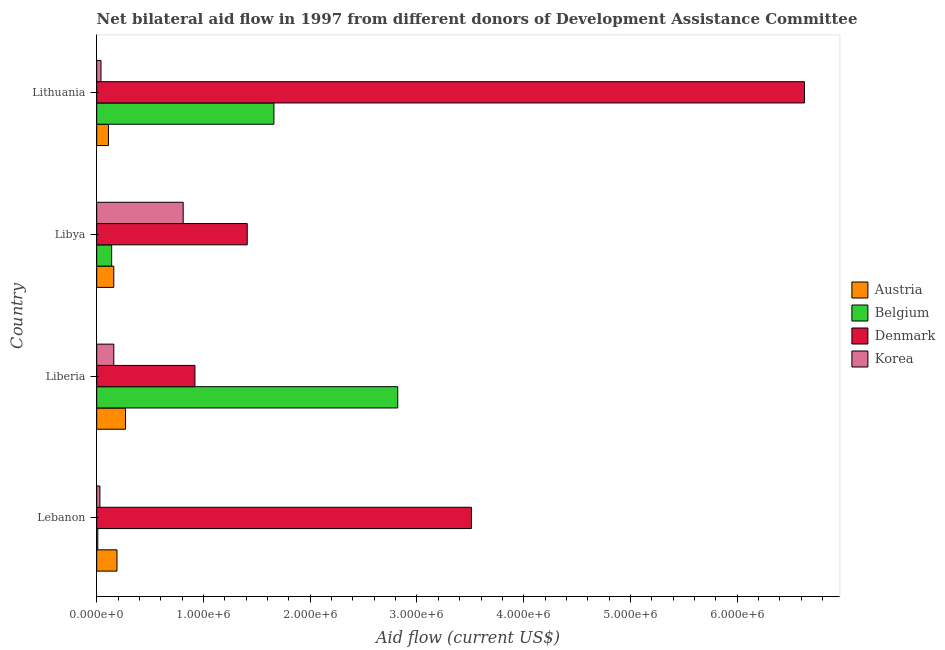How many different coloured bars are there?
Keep it short and to the point. 4. How many bars are there on the 1st tick from the top?
Your answer should be compact. 4. How many bars are there on the 4th tick from the bottom?
Your response must be concise. 4. What is the label of the 3rd group of bars from the top?
Offer a terse response. Liberia. What is the amount of aid given by belgium in Lebanon?
Keep it short and to the point. 10000. Across all countries, what is the maximum amount of aid given by korea?
Ensure brevity in your answer.  8.10e+05. Across all countries, what is the minimum amount of aid given by belgium?
Your answer should be compact. 10000. In which country was the amount of aid given by korea maximum?
Provide a short and direct response. Libya. In which country was the amount of aid given by austria minimum?
Offer a very short reply. Lithuania. What is the total amount of aid given by korea in the graph?
Provide a short and direct response. 1.04e+06. What is the difference between the amount of aid given by austria in Lebanon and that in Libya?
Offer a very short reply. 3.00e+04. What is the difference between the amount of aid given by korea in Lebanon and the amount of aid given by belgium in Liberia?
Provide a succinct answer. -2.79e+06. What is the average amount of aid given by korea per country?
Offer a terse response. 2.60e+05. What is the difference between the amount of aid given by austria and amount of aid given by denmark in Lebanon?
Provide a short and direct response. -3.32e+06. What is the ratio of the amount of aid given by korea in Lebanon to that in Libya?
Your answer should be very brief. 0.04. What is the difference between the highest and the second highest amount of aid given by denmark?
Provide a succinct answer. 3.12e+06. What is the difference between the highest and the lowest amount of aid given by korea?
Offer a terse response. 7.80e+05. Is the sum of the amount of aid given by belgium in Liberia and Lithuania greater than the maximum amount of aid given by denmark across all countries?
Make the answer very short. No. What does the 2nd bar from the top in Lebanon represents?
Your response must be concise. Denmark. Is it the case that in every country, the sum of the amount of aid given by austria and amount of aid given by belgium is greater than the amount of aid given by denmark?
Give a very brief answer. No. What is the difference between two consecutive major ticks on the X-axis?
Give a very brief answer. 1.00e+06. Does the graph contain any zero values?
Provide a short and direct response. No. Where does the legend appear in the graph?
Offer a very short reply. Center right. How many legend labels are there?
Your response must be concise. 4. How are the legend labels stacked?
Make the answer very short. Vertical. What is the title of the graph?
Your answer should be compact. Net bilateral aid flow in 1997 from different donors of Development Assistance Committee. What is the label or title of the X-axis?
Provide a succinct answer. Aid flow (current US$). What is the label or title of the Y-axis?
Offer a terse response. Country. What is the Aid flow (current US$) of Belgium in Lebanon?
Keep it short and to the point. 10000. What is the Aid flow (current US$) of Denmark in Lebanon?
Offer a terse response. 3.51e+06. What is the Aid flow (current US$) of Austria in Liberia?
Offer a terse response. 2.70e+05. What is the Aid flow (current US$) of Belgium in Liberia?
Offer a terse response. 2.82e+06. What is the Aid flow (current US$) of Denmark in Liberia?
Keep it short and to the point. 9.20e+05. What is the Aid flow (current US$) in Austria in Libya?
Provide a succinct answer. 1.60e+05. What is the Aid flow (current US$) in Belgium in Libya?
Offer a very short reply. 1.40e+05. What is the Aid flow (current US$) of Denmark in Libya?
Keep it short and to the point. 1.41e+06. What is the Aid flow (current US$) in Korea in Libya?
Offer a terse response. 8.10e+05. What is the Aid flow (current US$) in Belgium in Lithuania?
Provide a succinct answer. 1.66e+06. What is the Aid flow (current US$) of Denmark in Lithuania?
Your answer should be very brief. 6.63e+06. Across all countries, what is the maximum Aid flow (current US$) of Austria?
Provide a short and direct response. 2.70e+05. Across all countries, what is the maximum Aid flow (current US$) of Belgium?
Give a very brief answer. 2.82e+06. Across all countries, what is the maximum Aid flow (current US$) of Denmark?
Give a very brief answer. 6.63e+06. Across all countries, what is the maximum Aid flow (current US$) in Korea?
Your answer should be compact. 8.10e+05. Across all countries, what is the minimum Aid flow (current US$) in Austria?
Ensure brevity in your answer.  1.10e+05. Across all countries, what is the minimum Aid flow (current US$) of Denmark?
Your answer should be very brief. 9.20e+05. Across all countries, what is the minimum Aid flow (current US$) in Korea?
Provide a short and direct response. 3.00e+04. What is the total Aid flow (current US$) of Austria in the graph?
Provide a short and direct response. 7.30e+05. What is the total Aid flow (current US$) in Belgium in the graph?
Your response must be concise. 4.63e+06. What is the total Aid flow (current US$) of Denmark in the graph?
Provide a short and direct response. 1.25e+07. What is the total Aid flow (current US$) in Korea in the graph?
Your response must be concise. 1.04e+06. What is the difference between the Aid flow (current US$) in Belgium in Lebanon and that in Liberia?
Provide a short and direct response. -2.81e+06. What is the difference between the Aid flow (current US$) of Denmark in Lebanon and that in Liberia?
Your response must be concise. 2.59e+06. What is the difference between the Aid flow (current US$) of Austria in Lebanon and that in Libya?
Offer a very short reply. 3.00e+04. What is the difference between the Aid flow (current US$) of Belgium in Lebanon and that in Libya?
Your response must be concise. -1.30e+05. What is the difference between the Aid flow (current US$) of Denmark in Lebanon and that in Libya?
Offer a terse response. 2.10e+06. What is the difference between the Aid flow (current US$) in Korea in Lebanon and that in Libya?
Make the answer very short. -7.80e+05. What is the difference between the Aid flow (current US$) in Austria in Lebanon and that in Lithuania?
Your answer should be very brief. 8.00e+04. What is the difference between the Aid flow (current US$) of Belgium in Lebanon and that in Lithuania?
Your answer should be very brief. -1.65e+06. What is the difference between the Aid flow (current US$) in Denmark in Lebanon and that in Lithuania?
Offer a very short reply. -3.12e+06. What is the difference between the Aid flow (current US$) of Korea in Lebanon and that in Lithuania?
Keep it short and to the point. -10000. What is the difference between the Aid flow (current US$) of Austria in Liberia and that in Libya?
Offer a very short reply. 1.10e+05. What is the difference between the Aid flow (current US$) of Belgium in Liberia and that in Libya?
Your answer should be very brief. 2.68e+06. What is the difference between the Aid flow (current US$) of Denmark in Liberia and that in Libya?
Offer a terse response. -4.90e+05. What is the difference between the Aid flow (current US$) in Korea in Liberia and that in Libya?
Your response must be concise. -6.50e+05. What is the difference between the Aid flow (current US$) of Belgium in Liberia and that in Lithuania?
Keep it short and to the point. 1.16e+06. What is the difference between the Aid flow (current US$) of Denmark in Liberia and that in Lithuania?
Give a very brief answer. -5.71e+06. What is the difference between the Aid flow (current US$) of Korea in Liberia and that in Lithuania?
Keep it short and to the point. 1.20e+05. What is the difference between the Aid flow (current US$) of Austria in Libya and that in Lithuania?
Offer a terse response. 5.00e+04. What is the difference between the Aid flow (current US$) of Belgium in Libya and that in Lithuania?
Your response must be concise. -1.52e+06. What is the difference between the Aid flow (current US$) in Denmark in Libya and that in Lithuania?
Your answer should be very brief. -5.22e+06. What is the difference between the Aid flow (current US$) in Korea in Libya and that in Lithuania?
Provide a succinct answer. 7.70e+05. What is the difference between the Aid flow (current US$) of Austria in Lebanon and the Aid flow (current US$) of Belgium in Liberia?
Provide a short and direct response. -2.63e+06. What is the difference between the Aid flow (current US$) of Austria in Lebanon and the Aid flow (current US$) of Denmark in Liberia?
Provide a short and direct response. -7.30e+05. What is the difference between the Aid flow (current US$) in Austria in Lebanon and the Aid flow (current US$) in Korea in Liberia?
Give a very brief answer. 3.00e+04. What is the difference between the Aid flow (current US$) in Belgium in Lebanon and the Aid flow (current US$) in Denmark in Liberia?
Offer a very short reply. -9.10e+05. What is the difference between the Aid flow (current US$) of Denmark in Lebanon and the Aid flow (current US$) of Korea in Liberia?
Offer a very short reply. 3.35e+06. What is the difference between the Aid flow (current US$) of Austria in Lebanon and the Aid flow (current US$) of Denmark in Libya?
Your response must be concise. -1.22e+06. What is the difference between the Aid flow (current US$) of Austria in Lebanon and the Aid flow (current US$) of Korea in Libya?
Make the answer very short. -6.20e+05. What is the difference between the Aid flow (current US$) of Belgium in Lebanon and the Aid flow (current US$) of Denmark in Libya?
Provide a short and direct response. -1.40e+06. What is the difference between the Aid flow (current US$) of Belgium in Lebanon and the Aid flow (current US$) of Korea in Libya?
Your answer should be very brief. -8.00e+05. What is the difference between the Aid flow (current US$) in Denmark in Lebanon and the Aid flow (current US$) in Korea in Libya?
Make the answer very short. 2.70e+06. What is the difference between the Aid flow (current US$) in Austria in Lebanon and the Aid flow (current US$) in Belgium in Lithuania?
Offer a very short reply. -1.47e+06. What is the difference between the Aid flow (current US$) in Austria in Lebanon and the Aid flow (current US$) in Denmark in Lithuania?
Your answer should be very brief. -6.44e+06. What is the difference between the Aid flow (current US$) in Austria in Lebanon and the Aid flow (current US$) in Korea in Lithuania?
Provide a short and direct response. 1.50e+05. What is the difference between the Aid flow (current US$) of Belgium in Lebanon and the Aid flow (current US$) of Denmark in Lithuania?
Provide a short and direct response. -6.62e+06. What is the difference between the Aid flow (current US$) of Denmark in Lebanon and the Aid flow (current US$) of Korea in Lithuania?
Keep it short and to the point. 3.47e+06. What is the difference between the Aid flow (current US$) of Austria in Liberia and the Aid flow (current US$) of Denmark in Libya?
Make the answer very short. -1.14e+06. What is the difference between the Aid flow (current US$) in Austria in Liberia and the Aid flow (current US$) in Korea in Libya?
Ensure brevity in your answer.  -5.40e+05. What is the difference between the Aid flow (current US$) of Belgium in Liberia and the Aid flow (current US$) of Denmark in Libya?
Your answer should be compact. 1.41e+06. What is the difference between the Aid flow (current US$) in Belgium in Liberia and the Aid flow (current US$) in Korea in Libya?
Keep it short and to the point. 2.01e+06. What is the difference between the Aid flow (current US$) of Denmark in Liberia and the Aid flow (current US$) of Korea in Libya?
Offer a terse response. 1.10e+05. What is the difference between the Aid flow (current US$) in Austria in Liberia and the Aid flow (current US$) in Belgium in Lithuania?
Give a very brief answer. -1.39e+06. What is the difference between the Aid flow (current US$) of Austria in Liberia and the Aid flow (current US$) of Denmark in Lithuania?
Make the answer very short. -6.36e+06. What is the difference between the Aid flow (current US$) in Austria in Liberia and the Aid flow (current US$) in Korea in Lithuania?
Offer a terse response. 2.30e+05. What is the difference between the Aid flow (current US$) of Belgium in Liberia and the Aid flow (current US$) of Denmark in Lithuania?
Your answer should be very brief. -3.81e+06. What is the difference between the Aid flow (current US$) in Belgium in Liberia and the Aid flow (current US$) in Korea in Lithuania?
Keep it short and to the point. 2.78e+06. What is the difference between the Aid flow (current US$) of Denmark in Liberia and the Aid flow (current US$) of Korea in Lithuania?
Provide a short and direct response. 8.80e+05. What is the difference between the Aid flow (current US$) of Austria in Libya and the Aid flow (current US$) of Belgium in Lithuania?
Your answer should be compact. -1.50e+06. What is the difference between the Aid flow (current US$) in Austria in Libya and the Aid flow (current US$) in Denmark in Lithuania?
Provide a short and direct response. -6.47e+06. What is the difference between the Aid flow (current US$) in Belgium in Libya and the Aid flow (current US$) in Denmark in Lithuania?
Your answer should be compact. -6.49e+06. What is the difference between the Aid flow (current US$) in Denmark in Libya and the Aid flow (current US$) in Korea in Lithuania?
Your response must be concise. 1.37e+06. What is the average Aid flow (current US$) in Austria per country?
Offer a terse response. 1.82e+05. What is the average Aid flow (current US$) in Belgium per country?
Keep it short and to the point. 1.16e+06. What is the average Aid flow (current US$) of Denmark per country?
Your answer should be compact. 3.12e+06. What is the average Aid flow (current US$) of Korea per country?
Ensure brevity in your answer.  2.60e+05. What is the difference between the Aid flow (current US$) in Austria and Aid flow (current US$) in Belgium in Lebanon?
Provide a succinct answer. 1.80e+05. What is the difference between the Aid flow (current US$) of Austria and Aid flow (current US$) of Denmark in Lebanon?
Offer a very short reply. -3.32e+06. What is the difference between the Aid flow (current US$) of Belgium and Aid flow (current US$) of Denmark in Lebanon?
Offer a very short reply. -3.50e+06. What is the difference between the Aid flow (current US$) of Belgium and Aid flow (current US$) of Korea in Lebanon?
Offer a terse response. -2.00e+04. What is the difference between the Aid flow (current US$) in Denmark and Aid flow (current US$) in Korea in Lebanon?
Provide a short and direct response. 3.48e+06. What is the difference between the Aid flow (current US$) of Austria and Aid flow (current US$) of Belgium in Liberia?
Provide a succinct answer. -2.55e+06. What is the difference between the Aid flow (current US$) of Austria and Aid flow (current US$) of Denmark in Liberia?
Your response must be concise. -6.50e+05. What is the difference between the Aid flow (current US$) in Austria and Aid flow (current US$) in Korea in Liberia?
Your answer should be very brief. 1.10e+05. What is the difference between the Aid flow (current US$) of Belgium and Aid flow (current US$) of Denmark in Liberia?
Offer a very short reply. 1.90e+06. What is the difference between the Aid flow (current US$) in Belgium and Aid flow (current US$) in Korea in Liberia?
Your answer should be compact. 2.66e+06. What is the difference between the Aid flow (current US$) in Denmark and Aid flow (current US$) in Korea in Liberia?
Keep it short and to the point. 7.60e+05. What is the difference between the Aid flow (current US$) in Austria and Aid flow (current US$) in Belgium in Libya?
Make the answer very short. 2.00e+04. What is the difference between the Aid flow (current US$) in Austria and Aid flow (current US$) in Denmark in Libya?
Offer a very short reply. -1.25e+06. What is the difference between the Aid flow (current US$) in Austria and Aid flow (current US$) in Korea in Libya?
Provide a succinct answer. -6.50e+05. What is the difference between the Aid flow (current US$) of Belgium and Aid flow (current US$) of Denmark in Libya?
Your response must be concise. -1.27e+06. What is the difference between the Aid flow (current US$) of Belgium and Aid flow (current US$) of Korea in Libya?
Keep it short and to the point. -6.70e+05. What is the difference between the Aid flow (current US$) of Austria and Aid flow (current US$) of Belgium in Lithuania?
Make the answer very short. -1.55e+06. What is the difference between the Aid flow (current US$) of Austria and Aid flow (current US$) of Denmark in Lithuania?
Your response must be concise. -6.52e+06. What is the difference between the Aid flow (current US$) in Austria and Aid flow (current US$) in Korea in Lithuania?
Provide a succinct answer. 7.00e+04. What is the difference between the Aid flow (current US$) in Belgium and Aid flow (current US$) in Denmark in Lithuania?
Offer a very short reply. -4.97e+06. What is the difference between the Aid flow (current US$) of Belgium and Aid flow (current US$) of Korea in Lithuania?
Your response must be concise. 1.62e+06. What is the difference between the Aid flow (current US$) in Denmark and Aid flow (current US$) in Korea in Lithuania?
Provide a short and direct response. 6.59e+06. What is the ratio of the Aid flow (current US$) of Austria in Lebanon to that in Liberia?
Give a very brief answer. 0.7. What is the ratio of the Aid flow (current US$) in Belgium in Lebanon to that in Liberia?
Ensure brevity in your answer.  0. What is the ratio of the Aid flow (current US$) of Denmark in Lebanon to that in Liberia?
Provide a succinct answer. 3.82. What is the ratio of the Aid flow (current US$) of Korea in Lebanon to that in Liberia?
Offer a terse response. 0.19. What is the ratio of the Aid flow (current US$) in Austria in Lebanon to that in Libya?
Keep it short and to the point. 1.19. What is the ratio of the Aid flow (current US$) of Belgium in Lebanon to that in Libya?
Offer a terse response. 0.07. What is the ratio of the Aid flow (current US$) in Denmark in Lebanon to that in Libya?
Give a very brief answer. 2.49. What is the ratio of the Aid flow (current US$) of Korea in Lebanon to that in Libya?
Your answer should be very brief. 0.04. What is the ratio of the Aid flow (current US$) in Austria in Lebanon to that in Lithuania?
Your response must be concise. 1.73. What is the ratio of the Aid flow (current US$) in Belgium in Lebanon to that in Lithuania?
Your response must be concise. 0.01. What is the ratio of the Aid flow (current US$) in Denmark in Lebanon to that in Lithuania?
Make the answer very short. 0.53. What is the ratio of the Aid flow (current US$) of Austria in Liberia to that in Libya?
Offer a very short reply. 1.69. What is the ratio of the Aid flow (current US$) of Belgium in Liberia to that in Libya?
Your answer should be compact. 20.14. What is the ratio of the Aid flow (current US$) in Denmark in Liberia to that in Libya?
Offer a terse response. 0.65. What is the ratio of the Aid flow (current US$) in Korea in Liberia to that in Libya?
Provide a short and direct response. 0.2. What is the ratio of the Aid flow (current US$) in Austria in Liberia to that in Lithuania?
Ensure brevity in your answer.  2.45. What is the ratio of the Aid flow (current US$) in Belgium in Liberia to that in Lithuania?
Offer a very short reply. 1.7. What is the ratio of the Aid flow (current US$) in Denmark in Liberia to that in Lithuania?
Your response must be concise. 0.14. What is the ratio of the Aid flow (current US$) of Korea in Liberia to that in Lithuania?
Make the answer very short. 4. What is the ratio of the Aid flow (current US$) of Austria in Libya to that in Lithuania?
Ensure brevity in your answer.  1.45. What is the ratio of the Aid flow (current US$) in Belgium in Libya to that in Lithuania?
Provide a short and direct response. 0.08. What is the ratio of the Aid flow (current US$) in Denmark in Libya to that in Lithuania?
Give a very brief answer. 0.21. What is the ratio of the Aid flow (current US$) in Korea in Libya to that in Lithuania?
Provide a short and direct response. 20.25. What is the difference between the highest and the second highest Aid flow (current US$) in Austria?
Your response must be concise. 8.00e+04. What is the difference between the highest and the second highest Aid flow (current US$) of Belgium?
Your response must be concise. 1.16e+06. What is the difference between the highest and the second highest Aid flow (current US$) of Denmark?
Offer a terse response. 3.12e+06. What is the difference between the highest and the second highest Aid flow (current US$) in Korea?
Keep it short and to the point. 6.50e+05. What is the difference between the highest and the lowest Aid flow (current US$) of Austria?
Keep it short and to the point. 1.60e+05. What is the difference between the highest and the lowest Aid flow (current US$) of Belgium?
Offer a very short reply. 2.81e+06. What is the difference between the highest and the lowest Aid flow (current US$) in Denmark?
Make the answer very short. 5.71e+06. What is the difference between the highest and the lowest Aid flow (current US$) of Korea?
Provide a succinct answer. 7.80e+05. 